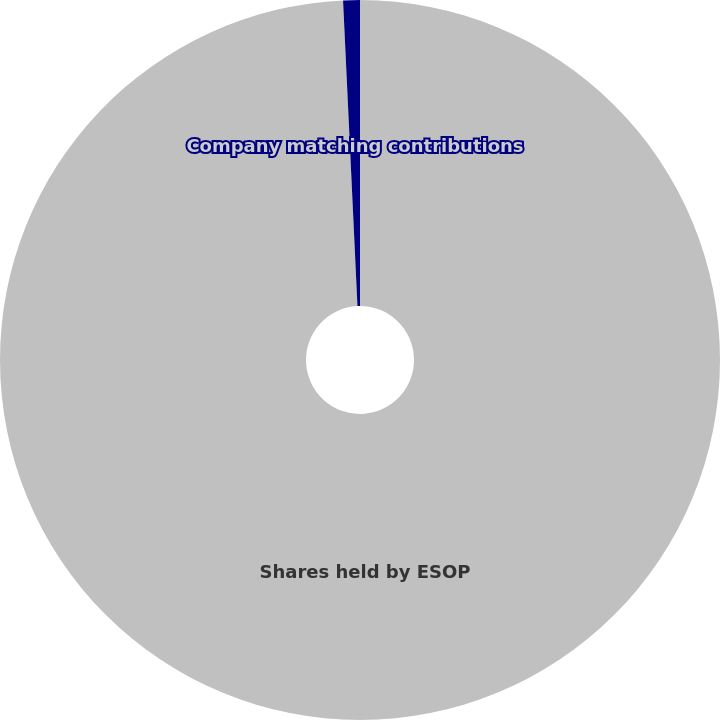Convert chart. <chart><loc_0><loc_0><loc_500><loc_500><pie_chart><fcel>Shares held by ESOP<fcel>Company matching contributions<nl><fcel>99.25%<fcel>0.75%<nl></chart> 